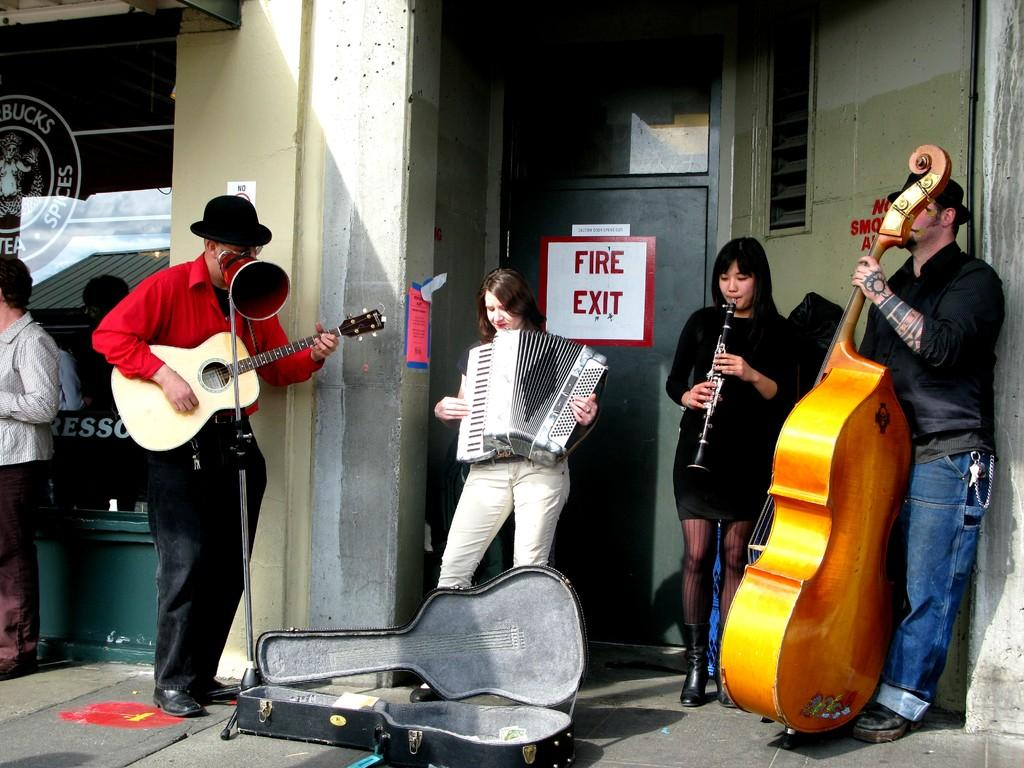How many people are in the image? There is a group of persons in the image. What are the persons in the image doing? The persons are playing musical instruments. Where are the persons standing in the image? The persons are standing on the floor. What type of banana is being used as a drumstick in the image? There is no banana present in the image, and therefore no such use can be observed. 